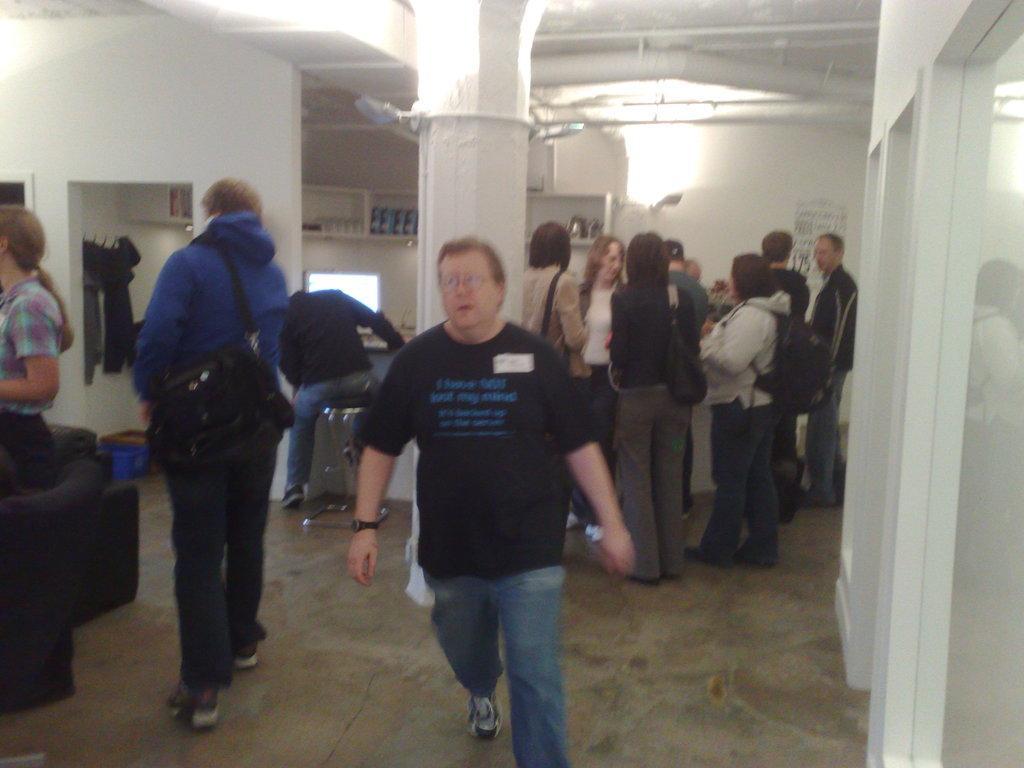In one or two sentences, can you explain what this image depicts? These two people are walking and this man wore bag,these people are standing. We can see chair and pillar. In the background we can see wall and light. 